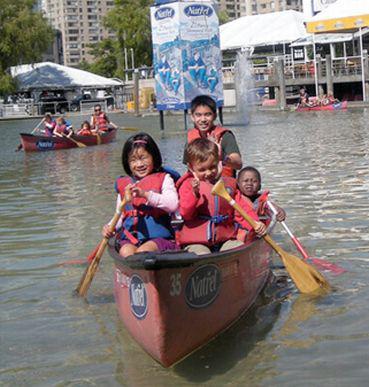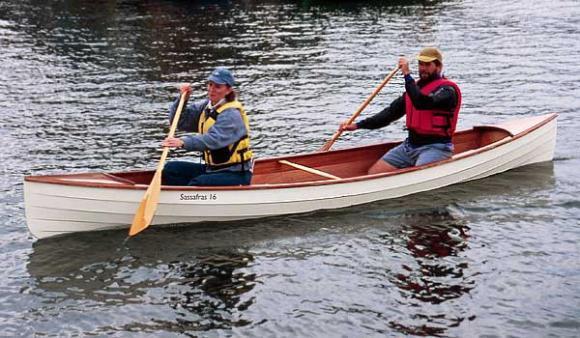The first image is the image on the left, the second image is the image on the right. Evaluate the accuracy of this statement regarding the images: "Right image shows a canoe holding three people who all wear red life vests.". Is it true? Answer yes or no. No. 